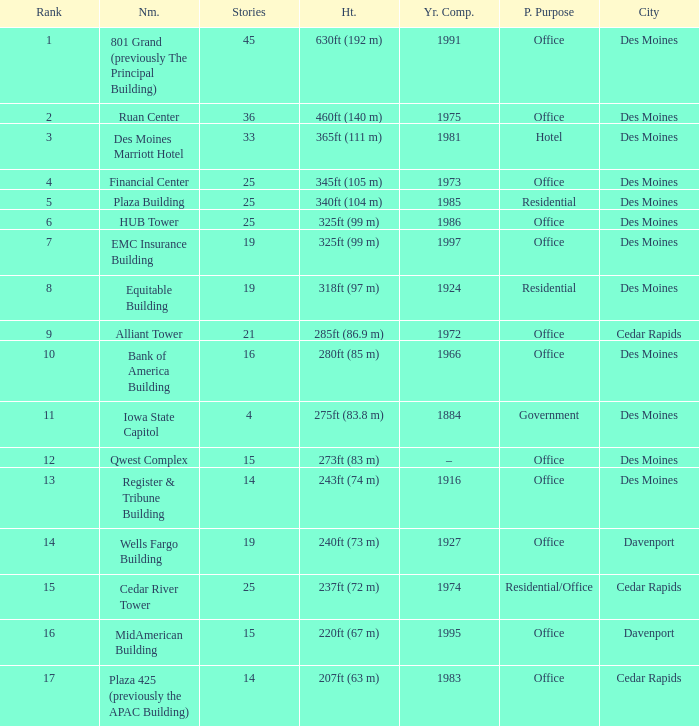What is the height of the EMC Insurance Building in Des Moines? 325ft (99 m). 